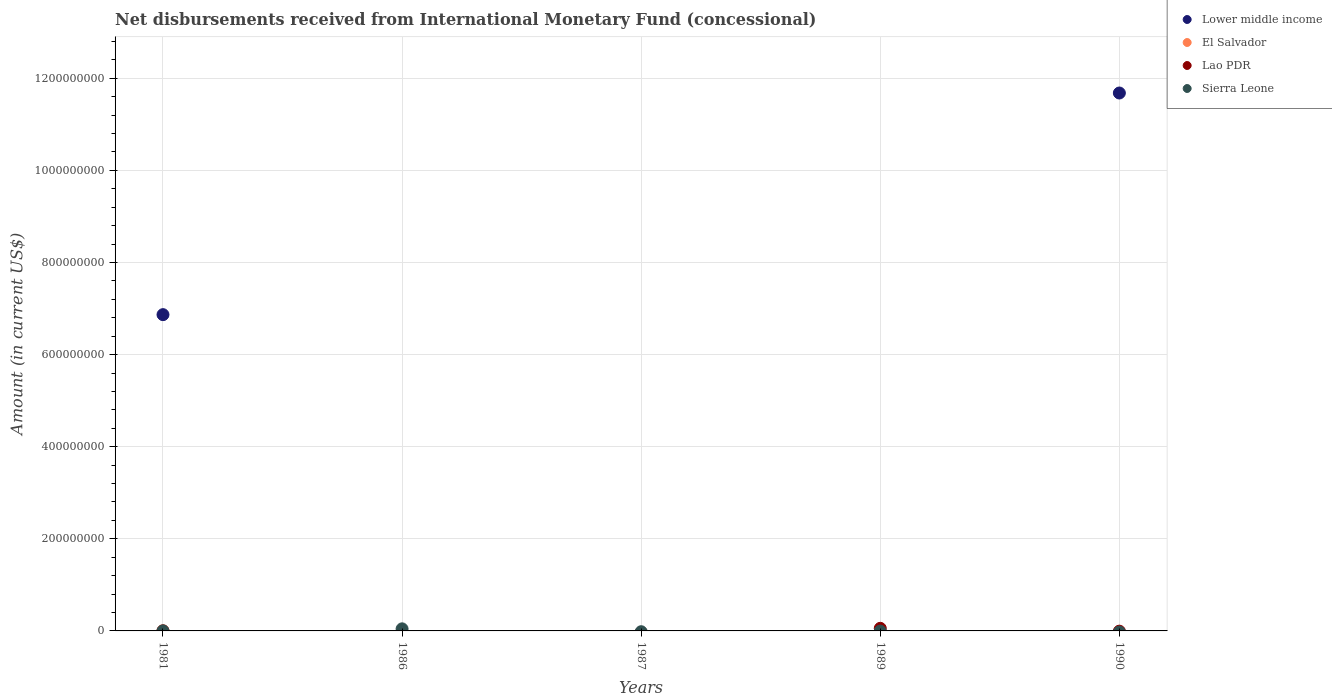How many different coloured dotlines are there?
Provide a succinct answer. 4. What is the amount of disbursements received from International Monetary Fund in Lower middle income in 1990?
Your response must be concise. 1.17e+09. Across all years, what is the maximum amount of disbursements received from International Monetary Fund in Sierra Leone?
Your answer should be very brief. 4.52e+06. Across all years, what is the minimum amount of disbursements received from International Monetary Fund in Lao PDR?
Provide a succinct answer. 0. What is the total amount of disbursements received from International Monetary Fund in Lower middle income in the graph?
Offer a terse response. 1.85e+09. What is the difference between the amount of disbursements received from International Monetary Fund in Lower middle income in 1981 and the amount of disbursements received from International Monetary Fund in Sierra Leone in 1986?
Give a very brief answer. 6.82e+08. What is the average amount of disbursements received from International Monetary Fund in Sierra Leone per year?
Offer a very short reply. 9.26e+05. In the year 1981, what is the difference between the amount of disbursements received from International Monetary Fund in Sierra Leone and amount of disbursements received from International Monetary Fund in Lao PDR?
Ensure brevity in your answer.  5.30e+04. In how many years, is the amount of disbursements received from International Monetary Fund in Sierra Leone greater than 360000000 US$?
Your response must be concise. 0. What is the ratio of the amount of disbursements received from International Monetary Fund in Lao PDR in 1981 to that in 1989?
Provide a short and direct response. 0.01. Is the amount of disbursements received from International Monetary Fund in Lao PDR in 1981 less than that in 1989?
Keep it short and to the point. Yes. What is the difference between the highest and the lowest amount of disbursements received from International Monetary Fund in Sierra Leone?
Keep it short and to the point. 4.52e+06. Does the amount of disbursements received from International Monetary Fund in Lower middle income monotonically increase over the years?
Give a very brief answer. No. Is the amount of disbursements received from International Monetary Fund in El Salvador strictly greater than the amount of disbursements received from International Monetary Fund in Lower middle income over the years?
Provide a succinct answer. No. How many dotlines are there?
Your answer should be very brief. 4. How many years are there in the graph?
Give a very brief answer. 5. Does the graph contain any zero values?
Provide a short and direct response. Yes. Where does the legend appear in the graph?
Your response must be concise. Top right. How many legend labels are there?
Keep it short and to the point. 4. What is the title of the graph?
Your answer should be compact. Net disbursements received from International Monetary Fund (concessional). Does "Bosnia and Herzegovina" appear as one of the legend labels in the graph?
Your response must be concise. No. What is the label or title of the X-axis?
Your answer should be compact. Years. What is the label or title of the Y-axis?
Keep it short and to the point. Amount (in current US$). What is the Amount (in current US$) of Lower middle income in 1981?
Offer a terse response. 6.87e+08. What is the Amount (in current US$) in El Salvador in 1981?
Your response must be concise. 1.56e+05. What is the Amount (in current US$) in Lao PDR in 1981?
Your answer should be compact. 5.80e+04. What is the Amount (in current US$) in Sierra Leone in 1981?
Keep it short and to the point. 1.11e+05. What is the Amount (in current US$) in Lower middle income in 1986?
Offer a very short reply. 0. What is the Amount (in current US$) in El Salvador in 1986?
Offer a terse response. 0. What is the Amount (in current US$) in Lao PDR in 1986?
Provide a succinct answer. 0. What is the Amount (in current US$) in Sierra Leone in 1986?
Your answer should be compact. 4.52e+06. What is the Amount (in current US$) in El Salvador in 1987?
Give a very brief answer. 0. What is the Amount (in current US$) in Lao PDR in 1987?
Give a very brief answer. 0. What is the Amount (in current US$) in Sierra Leone in 1987?
Ensure brevity in your answer.  0. What is the Amount (in current US$) of Lower middle income in 1989?
Offer a very short reply. 0. What is the Amount (in current US$) of El Salvador in 1989?
Make the answer very short. 0. What is the Amount (in current US$) of Lao PDR in 1989?
Make the answer very short. 5.65e+06. What is the Amount (in current US$) in Lower middle income in 1990?
Offer a very short reply. 1.17e+09. What is the Amount (in current US$) of Lao PDR in 1990?
Your answer should be very brief. 0. Across all years, what is the maximum Amount (in current US$) in Lower middle income?
Your answer should be compact. 1.17e+09. Across all years, what is the maximum Amount (in current US$) of El Salvador?
Ensure brevity in your answer.  1.56e+05. Across all years, what is the maximum Amount (in current US$) in Lao PDR?
Keep it short and to the point. 5.65e+06. Across all years, what is the maximum Amount (in current US$) of Sierra Leone?
Your response must be concise. 4.52e+06. Across all years, what is the minimum Amount (in current US$) in Lower middle income?
Offer a terse response. 0. Across all years, what is the minimum Amount (in current US$) in El Salvador?
Give a very brief answer. 0. Across all years, what is the minimum Amount (in current US$) of Lao PDR?
Your response must be concise. 0. Across all years, what is the minimum Amount (in current US$) in Sierra Leone?
Offer a terse response. 0. What is the total Amount (in current US$) of Lower middle income in the graph?
Offer a very short reply. 1.85e+09. What is the total Amount (in current US$) of El Salvador in the graph?
Your response must be concise. 1.56e+05. What is the total Amount (in current US$) in Lao PDR in the graph?
Offer a terse response. 5.71e+06. What is the total Amount (in current US$) in Sierra Leone in the graph?
Offer a terse response. 4.63e+06. What is the difference between the Amount (in current US$) of Sierra Leone in 1981 and that in 1986?
Ensure brevity in your answer.  -4.41e+06. What is the difference between the Amount (in current US$) in Lao PDR in 1981 and that in 1989?
Your answer should be compact. -5.59e+06. What is the difference between the Amount (in current US$) of Lower middle income in 1981 and that in 1990?
Offer a very short reply. -4.81e+08. What is the difference between the Amount (in current US$) of Lower middle income in 1981 and the Amount (in current US$) of Sierra Leone in 1986?
Offer a terse response. 6.82e+08. What is the difference between the Amount (in current US$) in El Salvador in 1981 and the Amount (in current US$) in Sierra Leone in 1986?
Your answer should be compact. -4.36e+06. What is the difference between the Amount (in current US$) in Lao PDR in 1981 and the Amount (in current US$) in Sierra Leone in 1986?
Offer a terse response. -4.46e+06. What is the difference between the Amount (in current US$) of Lower middle income in 1981 and the Amount (in current US$) of Lao PDR in 1989?
Your answer should be very brief. 6.81e+08. What is the difference between the Amount (in current US$) in El Salvador in 1981 and the Amount (in current US$) in Lao PDR in 1989?
Give a very brief answer. -5.49e+06. What is the average Amount (in current US$) of Lower middle income per year?
Offer a terse response. 3.71e+08. What is the average Amount (in current US$) in El Salvador per year?
Keep it short and to the point. 3.12e+04. What is the average Amount (in current US$) in Lao PDR per year?
Your response must be concise. 1.14e+06. What is the average Amount (in current US$) in Sierra Leone per year?
Ensure brevity in your answer.  9.26e+05. In the year 1981, what is the difference between the Amount (in current US$) in Lower middle income and Amount (in current US$) in El Salvador?
Offer a terse response. 6.87e+08. In the year 1981, what is the difference between the Amount (in current US$) of Lower middle income and Amount (in current US$) of Lao PDR?
Give a very brief answer. 6.87e+08. In the year 1981, what is the difference between the Amount (in current US$) in Lower middle income and Amount (in current US$) in Sierra Leone?
Your answer should be compact. 6.87e+08. In the year 1981, what is the difference between the Amount (in current US$) of El Salvador and Amount (in current US$) of Lao PDR?
Your answer should be compact. 9.80e+04. In the year 1981, what is the difference between the Amount (in current US$) in El Salvador and Amount (in current US$) in Sierra Leone?
Make the answer very short. 4.50e+04. In the year 1981, what is the difference between the Amount (in current US$) in Lao PDR and Amount (in current US$) in Sierra Leone?
Your answer should be compact. -5.30e+04. What is the ratio of the Amount (in current US$) in Sierra Leone in 1981 to that in 1986?
Provide a short and direct response. 0.02. What is the ratio of the Amount (in current US$) of Lao PDR in 1981 to that in 1989?
Provide a short and direct response. 0.01. What is the ratio of the Amount (in current US$) in Lower middle income in 1981 to that in 1990?
Ensure brevity in your answer.  0.59. What is the difference between the highest and the lowest Amount (in current US$) in Lower middle income?
Your answer should be compact. 1.17e+09. What is the difference between the highest and the lowest Amount (in current US$) in El Salvador?
Keep it short and to the point. 1.56e+05. What is the difference between the highest and the lowest Amount (in current US$) in Lao PDR?
Make the answer very short. 5.65e+06. What is the difference between the highest and the lowest Amount (in current US$) of Sierra Leone?
Your response must be concise. 4.52e+06. 